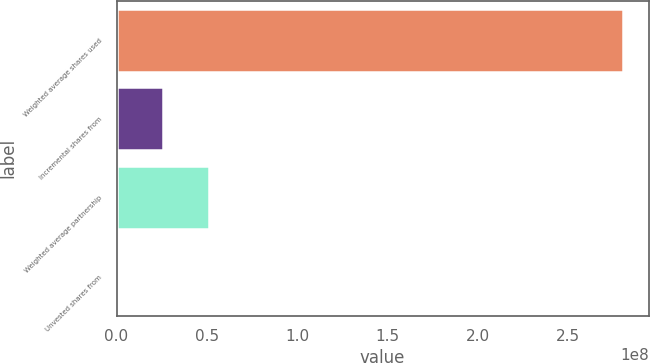Convert chart to OTSL. <chart><loc_0><loc_0><loc_500><loc_500><bar_chart><fcel>Weighted average shares used<fcel>Incremental shares from<fcel>Weighted average partnership<fcel>Unvested shares from<nl><fcel>2.80629e+08<fcel>2.55629e+07<fcel>5.11252e+07<fcel>475<nl></chart> 